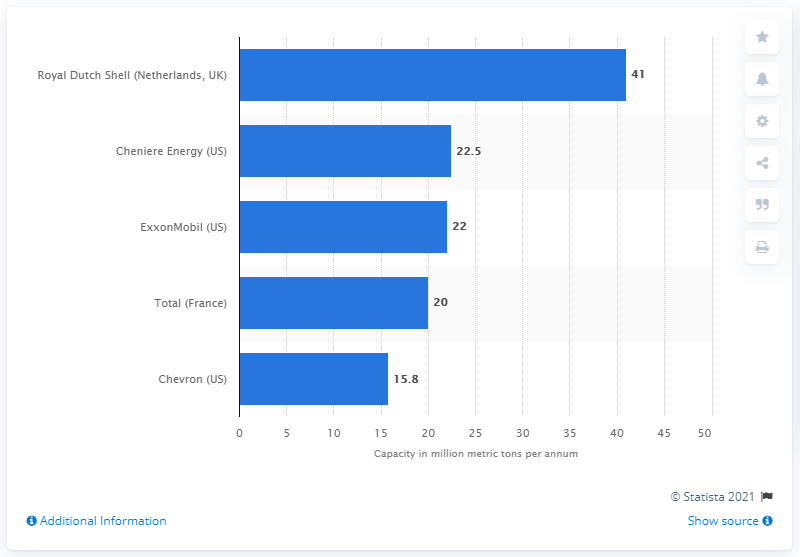Specify some key components in this picture. Royal Dutch Shell's annual capacity is approximately 41... 